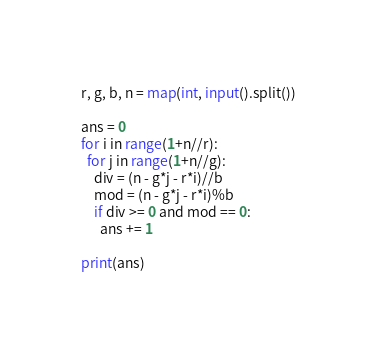Convert code to text. <code><loc_0><loc_0><loc_500><loc_500><_Python_>r, g, b, n = map(int, input().split())

ans = 0
for i in range(1+n//r):
  for j in range(1+n//g):
    div = (n - g*j - r*i)//b
    mod = (n - g*j - r*i)%b
    if div >= 0 and mod == 0:
      ans += 1
        
print(ans)</code> 